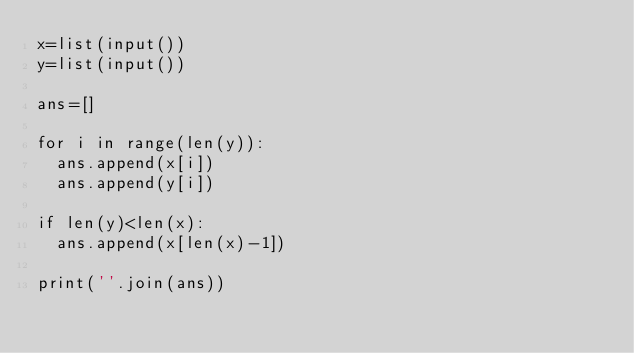Convert code to text. <code><loc_0><loc_0><loc_500><loc_500><_Python_>x=list(input())
y=list(input())

ans=[]

for i in range(len(y)):
  ans.append(x[i])
  ans.append(y[i])
  
if len(y)<len(x):
  ans.append(x[len(x)-1])
  
print(''.join(ans))</code> 